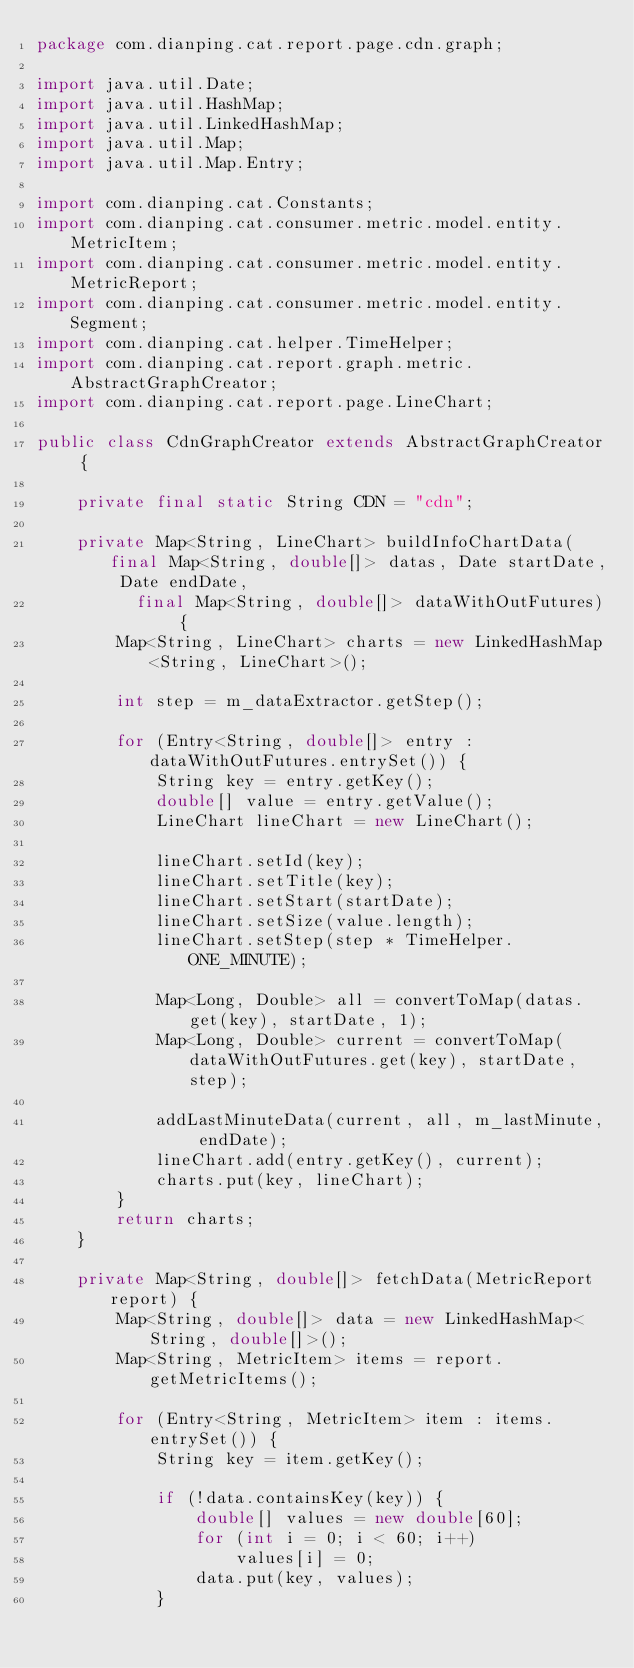Convert code to text. <code><loc_0><loc_0><loc_500><loc_500><_Java_>package com.dianping.cat.report.page.cdn.graph;

import java.util.Date;
import java.util.HashMap;
import java.util.LinkedHashMap;
import java.util.Map;
import java.util.Map.Entry;

import com.dianping.cat.Constants;
import com.dianping.cat.consumer.metric.model.entity.MetricItem;
import com.dianping.cat.consumer.metric.model.entity.MetricReport;
import com.dianping.cat.consumer.metric.model.entity.Segment;
import com.dianping.cat.helper.TimeHelper;
import com.dianping.cat.report.graph.metric.AbstractGraphCreator;
import com.dianping.cat.report.page.LineChart;

public class CdnGraphCreator extends AbstractGraphCreator {

	private final static String CDN = "cdn";

	private Map<String, LineChart> buildInfoChartData(final Map<String, double[]> datas, Date startDate, Date endDate,
	      final Map<String, double[]> dataWithOutFutures) {
		Map<String, LineChart> charts = new LinkedHashMap<String, LineChart>();

		int step = m_dataExtractor.getStep();

		for (Entry<String, double[]> entry : dataWithOutFutures.entrySet()) {
			String key = entry.getKey();
			double[] value = entry.getValue();
			LineChart lineChart = new LineChart();

			lineChart.setId(key);
			lineChart.setTitle(key);
			lineChart.setStart(startDate);
			lineChart.setSize(value.length);
			lineChart.setStep(step * TimeHelper.ONE_MINUTE);

			Map<Long, Double> all = convertToMap(datas.get(key), startDate, 1);
			Map<Long, Double> current = convertToMap(dataWithOutFutures.get(key), startDate, step);

			addLastMinuteData(current, all, m_lastMinute, endDate);
			lineChart.add(entry.getKey(), current);
			charts.put(key, lineChart);
		}
		return charts;
	}

	private Map<String, double[]> fetchData(MetricReport report) {
		Map<String, double[]> data = new LinkedHashMap<String, double[]>();
		Map<String, MetricItem> items = report.getMetricItems();

		for (Entry<String, MetricItem> item : items.entrySet()) {
			String key = item.getKey();

			if (!data.containsKey(key)) {
				double[] values = new double[60];
				for (int i = 0; i < 60; i++)
					values[i] = 0;
				data.put(key, values);
			}</code> 